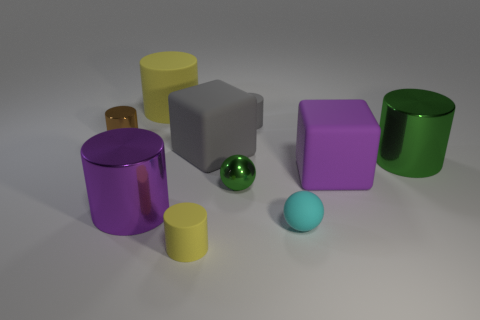What is the size of the thing that is the same color as the tiny metal ball?
Your answer should be very brief. Large. There is a small matte cylinder that is on the right side of the small yellow cylinder; does it have the same color as the tiny metal object behind the gray cube?
Ensure brevity in your answer.  No. What is the shape of the yellow rubber object that is the same size as the cyan object?
Provide a short and direct response. Cylinder. What number of objects are small rubber cylinders that are in front of the big purple matte cube or cubes that are behind the small cyan rubber sphere?
Your answer should be compact. 3. Are there fewer small yellow cylinders than small brown rubber blocks?
Give a very brief answer. No. There is a green sphere that is the same size as the cyan ball; what material is it?
Provide a short and direct response. Metal. There is a yellow cylinder behind the tiny gray matte object; is it the same size as the purple thing right of the big rubber cylinder?
Offer a very short reply. Yes. Are there any gray blocks made of the same material as the large purple block?
Your answer should be compact. Yes. How many objects are big metallic things that are in front of the tiny green metal ball or big cyan spheres?
Your response must be concise. 1. Is the material of the cylinder on the right side of the cyan rubber thing the same as the small green ball?
Keep it short and to the point. Yes. 